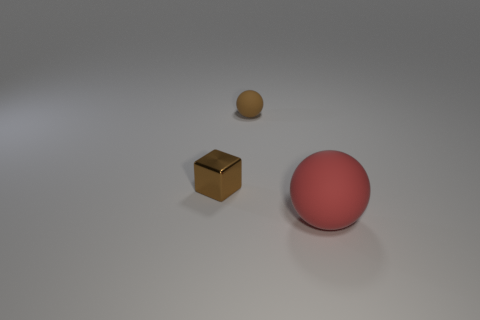The small object to the left of the brown thing that is to the right of the metallic thing is what color? The small object to the left of the brown cube, which is to the right of the metallic sphere, appears to be a smaller sphere with a shade ranging from beige to light brown, depending on the lighting. 